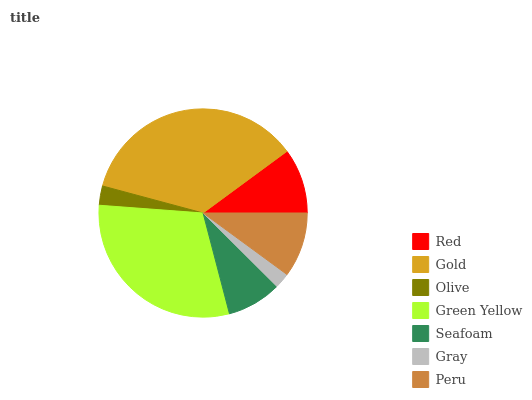Is Gray the minimum?
Answer yes or no. Yes. Is Gold the maximum?
Answer yes or no. Yes. Is Olive the minimum?
Answer yes or no. No. Is Olive the maximum?
Answer yes or no. No. Is Gold greater than Olive?
Answer yes or no. Yes. Is Olive less than Gold?
Answer yes or no. Yes. Is Olive greater than Gold?
Answer yes or no. No. Is Gold less than Olive?
Answer yes or no. No. Is Peru the high median?
Answer yes or no. Yes. Is Peru the low median?
Answer yes or no. Yes. Is Gray the high median?
Answer yes or no. No. Is Red the low median?
Answer yes or no. No. 